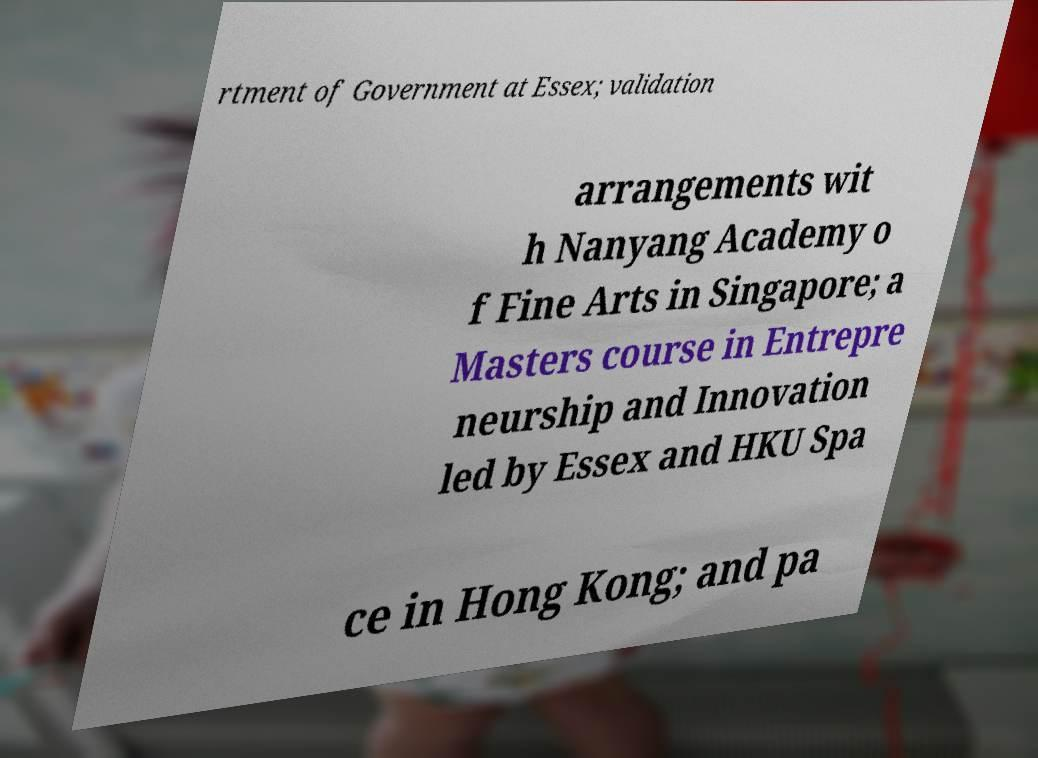For documentation purposes, I need the text within this image transcribed. Could you provide that? rtment of Government at Essex; validation arrangements wit h Nanyang Academy o f Fine Arts in Singapore; a Masters course in Entrepre neurship and Innovation led by Essex and HKU Spa ce in Hong Kong; and pa 